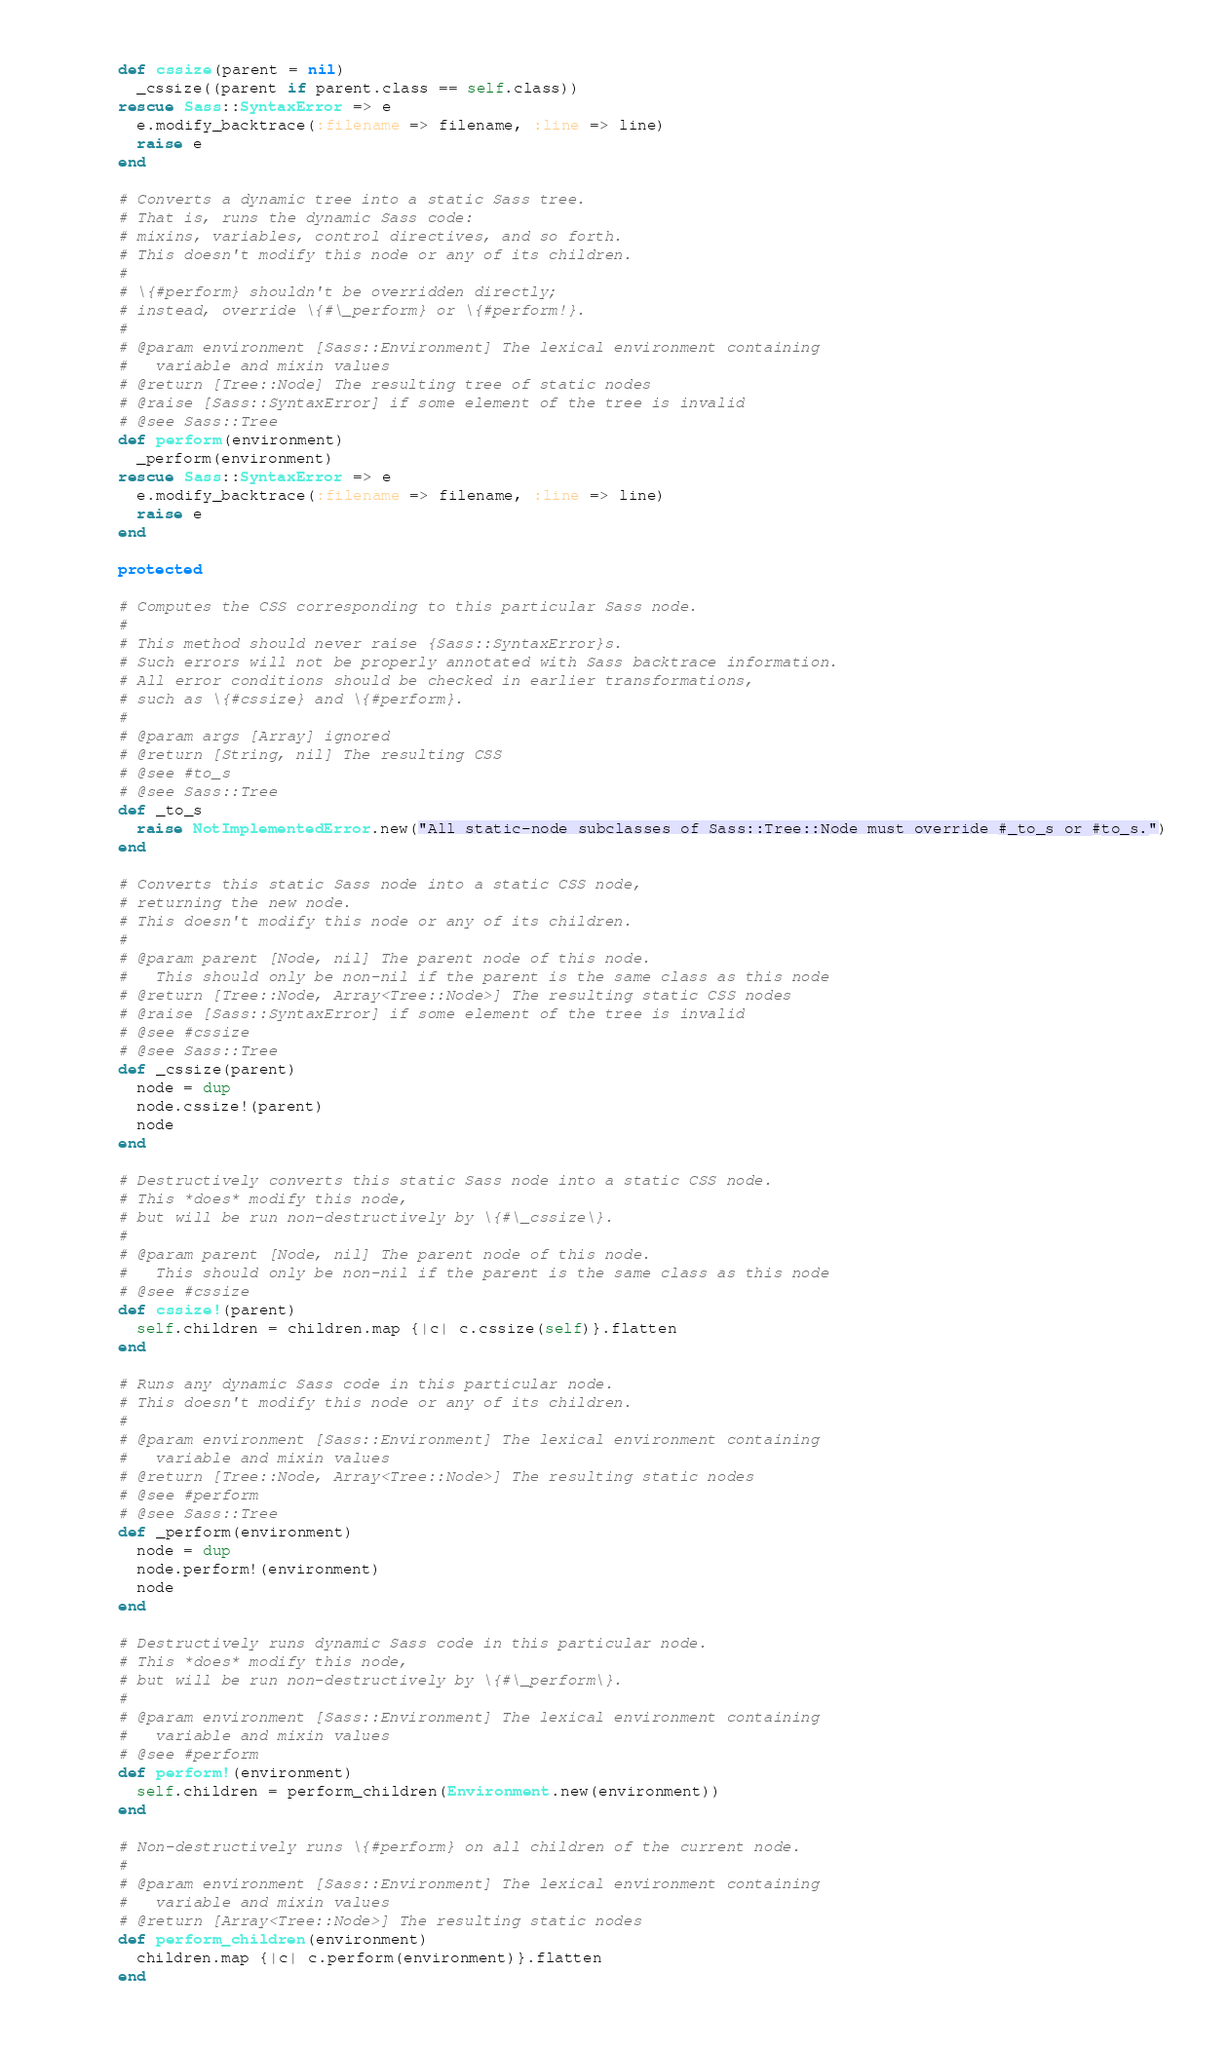Convert code to text. <code><loc_0><loc_0><loc_500><loc_500><_Ruby_>      def cssize(parent = nil)
        _cssize((parent if parent.class == self.class))
      rescue Sass::SyntaxError => e
        e.modify_backtrace(:filename => filename, :line => line)
        raise e
      end

      # Converts a dynamic tree into a static Sass tree.
      # That is, runs the dynamic Sass code:
      # mixins, variables, control directives, and so forth.
      # This doesn't modify this node or any of its children.
      #
      # \{#perform} shouldn't be overridden directly;
      # instead, override \{#\_perform} or \{#perform!}.
      #
      # @param environment [Sass::Environment] The lexical environment containing
      #   variable and mixin values
      # @return [Tree::Node] The resulting tree of static nodes
      # @raise [Sass::SyntaxError] if some element of the tree is invalid
      # @see Sass::Tree
      def perform(environment)
        _perform(environment)
      rescue Sass::SyntaxError => e
        e.modify_backtrace(:filename => filename, :line => line)
        raise e
      end

      protected

      # Computes the CSS corresponding to this particular Sass node.
      #
      # This method should never raise {Sass::SyntaxError}s.
      # Such errors will not be properly annotated with Sass backtrace information.
      # All error conditions should be checked in earlier transformations,
      # such as \{#cssize} and \{#perform}.
      #
      # @param args [Array] ignored
      # @return [String, nil] The resulting CSS
      # @see #to_s
      # @see Sass::Tree
      def _to_s
        raise NotImplementedError.new("All static-node subclasses of Sass::Tree::Node must override #_to_s or #to_s.")
      end

      # Converts this static Sass node into a static CSS node,
      # returning the new node.
      # This doesn't modify this node or any of its children.
      #
      # @param parent [Node, nil] The parent node of this node.
      #   This should only be non-nil if the parent is the same class as this node
      # @return [Tree::Node, Array<Tree::Node>] The resulting static CSS nodes
      # @raise [Sass::SyntaxError] if some element of the tree is invalid
      # @see #cssize
      # @see Sass::Tree
      def _cssize(parent)
        node = dup
        node.cssize!(parent)
        node
      end

      # Destructively converts this static Sass node into a static CSS node.
      # This *does* modify this node,
      # but will be run non-destructively by \{#\_cssize\}.
      #
      # @param parent [Node, nil] The parent node of this node.
      #   This should only be non-nil if the parent is the same class as this node
      # @see #cssize
      def cssize!(parent)
        self.children = children.map {|c| c.cssize(self)}.flatten
      end

      # Runs any dynamic Sass code in this particular node.
      # This doesn't modify this node or any of its children.
      #
      # @param environment [Sass::Environment] The lexical environment containing
      #   variable and mixin values
      # @return [Tree::Node, Array<Tree::Node>] The resulting static nodes
      # @see #perform
      # @see Sass::Tree
      def _perform(environment)
        node = dup
        node.perform!(environment)
        node
      end

      # Destructively runs dynamic Sass code in this particular node.
      # This *does* modify this node,
      # but will be run non-destructively by \{#\_perform\}.
      #
      # @param environment [Sass::Environment] The lexical environment containing
      #   variable and mixin values
      # @see #perform
      def perform!(environment)
        self.children = perform_children(Environment.new(environment))
      end

      # Non-destructively runs \{#perform} on all children of the current node.
      #
      # @param environment [Sass::Environment] The lexical environment containing
      #   variable and mixin values
      # @return [Array<Tree::Node>] The resulting static nodes
      def perform_children(environment)
        children.map {|c| c.perform(environment)}.flatten
      end
</code> 